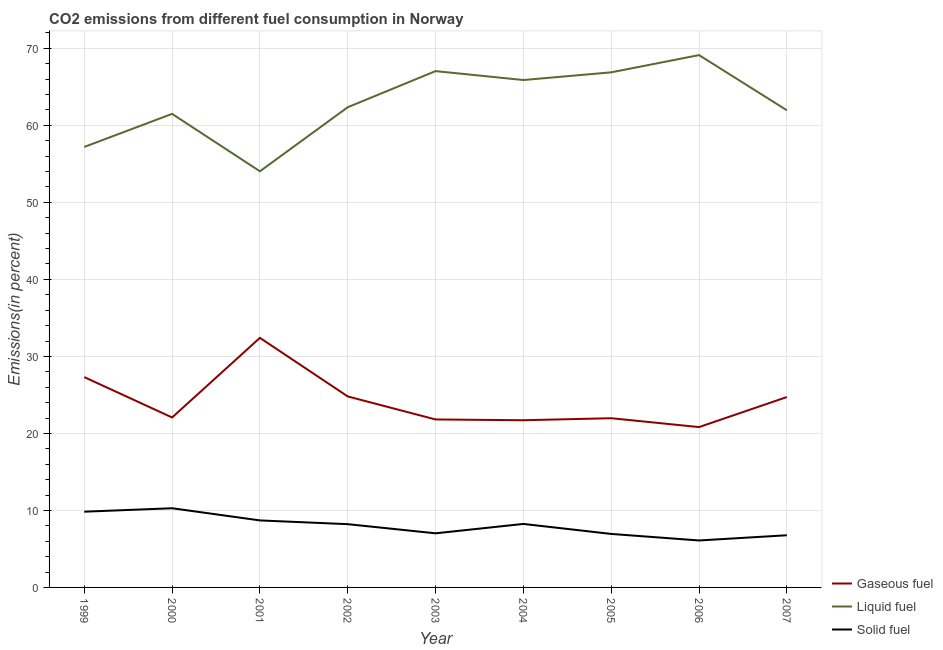How many different coloured lines are there?
Give a very brief answer. 3. Does the line corresponding to percentage of gaseous fuel emission intersect with the line corresponding to percentage of solid fuel emission?
Keep it short and to the point. No. What is the percentage of solid fuel emission in 2002?
Give a very brief answer. 8.22. Across all years, what is the maximum percentage of gaseous fuel emission?
Offer a terse response. 32.41. Across all years, what is the minimum percentage of solid fuel emission?
Give a very brief answer. 6.1. In which year was the percentage of gaseous fuel emission maximum?
Your answer should be compact. 2001. In which year was the percentage of solid fuel emission minimum?
Ensure brevity in your answer.  2006. What is the total percentage of solid fuel emission in the graph?
Your answer should be very brief. 72.13. What is the difference between the percentage of gaseous fuel emission in 2001 and that in 2007?
Ensure brevity in your answer.  7.69. What is the difference between the percentage of liquid fuel emission in 1999 and the percentage of gaseous fuel emission in 2001?
Offer a terse response. 24.79. What is the average percentage of liquid fuel emission per year?
Your answer should be compact. 62.89. In the year 2001, what is the difference between the percentage of gaseous fuel emission and percentage of solid fuel emission?
Keep it short and to the point. 23.71. In how many years, is the percentage of solid fuel emission greater than 26 %?
Your answer should be very brief. 0. What is the ratio of the percentage of liquid fuel emission in 2002 to that in 2004?
Make the answer very short. 0.95. Is the percentage of liquid fuel emission in 2001 less than that in 2002?
Provide a succinct answer. Yes. Is the difference between the percentage of liquid fuel emission in 2000 and 2006 greater than the difference between the percentage of solid fuel emission in 2000 and 2006?
Provide a succinct answer. No. What is the difference between the highest and the second highest percentage of liquid fuel emission?
Ensure brevity in your answer.  2.08. What is the difference between the highest and the lowest percentage of solid fuel emission?
Provide a short and direct response. 4.18. Is it the case that in every year, the sum of the percentage of gaseous fuel emission and percentage of liquid fuel emission is greater than the percentage of solid fuel emission?
Provide a succinct answer. Yes. Does the percentage of gaseous fuel emission monotonically increase over the years?
Ensure brevity in your answer.  No. How many years are there in the graph?
Your answer should be compact. 9. Does the graph contain grids?
Your answer should be compact. Yes. Where does the legend appear in the graph?
Your answer should be very brief. Bottom right. What is the title of the graph?
Offer a very short reply. CO2 emissions from different fuel consumption in Norway. Does "Gaseous fuel" appear as one of the legend labels in the graph?
Keep it short and to the point. Yes. What is the label or title of the X-axis?
Make the answer very short. Year. What is the label or title of the Y-axis?
Offer a very short reply. Emissions(in percent). What is the Emissions(in percent) in Gaseous fuel in 1999?
Offer a terse response. 27.31. What is the Emissions(in percent) of Liquid fuel in 1999?
Your answer should be very brief. 57.2. What is the Emissions(in percent) in Solid fuel in 1999?
Offer a very short reply. 9.83. What is the Emissions(in percent) in Gaseous fuel in 2000?
Your answer should be compact. 22.07. What is the Emissions(in percent) in Liquid fuel in 2000?
Your response must be concise. 61.49. What is the Emissions(in percent) of Solid fuel in 2000?
Provide a succinct answer. 10.28. What is the Emissions(in percent) of Gaseous fuel in 2001?
Offer a very short reply. 32.41. What is the Emissions(in percent) of Liquid fuel in 2001?
Keep it short and to the point. 54.04. What is the Emissions(in percent) in Solid fuel in 2001?
Your answer should be very brief. 8.7. What is the Emissions(in percent) in Gaseous fuel in 2002?
Your answer should be very brief. 24.8. What is the Emissions(in percent) of Liquid fuel in 2002?
Offer a very short reply. 62.36. What is the Emissions(in percent) of Solid fuel in 2002?
Keep it short and to the point. 8.22. What is the Emissions(in percent) of Gaseous fuel in 2003?
Your answer should be compact. 21.81. What is the Emissions(in percent) in Liquid fuel in 2003?
Offer a very short reply. 67.05. What is the Emissions(in percent) of Solid fuel in 2003?
Make the answer very short. 7.03. What is the Emissions(in percent) in Gaseous fuel in 2004?
Provide a short and direct response. 21.71. What is the Emissions(in percent) in Liquid fuel in 2004?
Provide a succinct answer. 65.89. What is the Emissions(in percent) in Solid fuel in 2004?
Your answer should be very brief. 8.25. What is the Emissions(in percent) in Gaseous fuel in 2005?
Provide a short and direct response. 21.97. What is the Emissions(in percent) in Liquid fuel in 2005?
Make the answer very short. 66.89. What is the Emissions(in percent) of Solid fuel in 2005?
Give a very brief answer. 6.95. What is the Emissions(in percent) in Gaseous fuel in 2006?
Keep it short and to the point. 20.82. What is the Emissions(in percent) of Liquid fuel in 2006?
Your answer should be compact. 69.13. What is the Emissions(in percent) in Solid fuel in 2006?
Ensure brevity in your answer.  6.1. What is the Emissions(in percent) in Gaseous fuel in 2007?
Provide a succinct answer. 24.72. What is the Emissions(in percent) of Liquid fuel in 2007?
Your response must be concise. 61.96. What is the Emissions(in percent) in Solid fuel in 2007?
Your response must be concise. 6.77. Across all years, what is the maximum Emissions(in percent) of Gaseous fuel?
Provide a succinct answer. 32.41. Across all years, what is the maximum Emissions(in percent) of Liquid fuel?
Ensure brevity in your answer.  69.13. Across all years, what is the maximum Emissions(in percent) of Solid fuel?
Give a very brief answer. 10.28. Across all years, what is the minimum Emissions(in percent) of Gaseous fuel?
Provide a succinct answer. 20.82. Across all years, what is the minimum Emissions(in percent) in Liquid fuel?
Your answer should be very brief. 54.04. Across all years, what is the minimum Emissions(in percent) of Solid fuel?
Give a very brief answer. 6.1. What is the total Emissions(in percent) in Gaseous fuel in the graph?
Keep it short and to the point. 217.63. What is the total Emissions(in percent) in Liquid fuel in the graph?
Your answer should be very brief. 566.01. What is the total Emissions(in percent) in Solid fuel in the graph?
Offer a very short reply. 72.13. What is the difference between the Emissions(in percent) of Gaseous fuel in 1999 and that in 2000?
Provide a succinct answer. 5.24. What is the difference between the Emissions(in percent) of Liquid fuel in 1999 and that in 2000?
Keep it short and to the point. -4.29. What is the difference between the Emissions(in percent) in Solid fuel in 1999 and that in 2000?
Ensure brevity in your answer.  -0.45. What is the difference between the Emissions(in percent) of Gaseous fuel in 1999 and that in 2001?
Provide a short and direct response. -5.1. What is the difference between the Emissions(in percent) in Liquid fuel in 1999 and that in 2001?
Give a very brief answer. 3.16. What is the difference between the Emissions(in percent) in Solid fuel in 1999 and that in 2001?
Offer a terse response. 1.13. What is the difference between the Emissions(in percent) of Gaseous fuel in 1999 and that in 2002?
Make the answer very short. 2.51. What is the difference between the Emissions(in percent) of Liquid fuel in 1999 and that in 2002?
Offer a terse response. -5.16. What is the difference between the Emissions(in percent) of Solid fuel in 1999 and that in 2002?
Provide a short and direct response. 1.62. What is the difference between the Emissions(in percent) of Gaseous fuel in 1999 and that in 2003?
Keep it short and to the point. 5.5. What is the difference between the Emissions(in percent) of Liquid fuel in 1999 and that in 2003?
Provide a succinct answer. -9.85. What is the difference between the Emissions(in percent) in Solid fuel in 1999 and that in 2003?
Your response must be concise. 2.81. What is the difference between the Emissions(in percent) in Gaseous fuel in 1999 and that in 2004?
Provide a succinct answer. 5.6. What is the difference between the Emissions(in percent) in Liquid fuel in 1999 and that in 2004?
Offer a terse response. -8.69. What is the difference between the Emissions(in percent) in Solid fuel in 1999 and that in 2004?
Make the answer very short. 1.59. What is the difference between the Emissions(in percent) of Gaseous fuel in 1999 and that in 2005?
Ensure brevity in your answer.  5.34. What is the difference between the Emissions(in percent) of Liquid fuel in 1999 and that in 2005?
Make the answer very short. -9.69. What is the difference between the Emissions(in percent) in Solid fuel in 1999 and that in 2005?
Provide a succinct answer. 2.89. What is the difference between the Emissions(in percent) in Gaseous fuel in 1999 and that in 2006?
Keep it short and to the point. 6.49. What is the difference between the Emissions(in percent) of Liquid fuel in 1999 and that in 2006?
Make the answer very short. -11.93. What is the difference between the Emissions(in percent) in Solid fuel in 1999 and that in 2006?
Give a very brief answer. 3.74. What is the difference between the Emissions(in percent) in Gaseous fuel in 1999 and that in 2007?
Keep it short and to the point. 2.59. What is the difference between the Emissions(in percent) in Liquid fuel in 1999 and that in 2007?
Make the answer very short. -4.76. What is the difference between the Emissions(in percent) in Solid fuel in 1999 and that in 2007?
Make the answer very short. 3.06. What is the difference between the Emissions(in percent) of Gaseous fuel in 2000 and that in 2001?
Your response must be concise. -10.34. What is the difference between the Emissions(in percent) in Liquid fuel in 2000 and that in 2001?
Your answer should be very brief. 7.46. What is the difference between the Emissions(in percent) in Solid fuel in 2000 and that in 2001?
Offer a very short reply. 1.58. What is the difference between the Emissions(in percent) of Gaseous fuel in 2000 and that in 2002?
Provide a short and direct response. -2.73. What is the difference between the Emissions(in percent) in Liquid fuel in 2000 and that in 2002?
Your response must be concise. -0.86. What is the difference between the Emissions(in percent) in Solid fuel in 2000 and that in 2002?
Provide a succinct answer. 2.07. What is the difference between the Emissions(in percent) of Gaseous fuel in 2000 and that in 2003?
Your answer should be very brief. 0.26. What is the difference between the Emissions(in percent) of Liquid fuel in 2000 and that in 2003?
Offer a terse response. -5.55. What is the difference between the Emissions(in percent) in Solid fuel in 2000 and that in 2003?
Your answer should be compact. 3.25. What is the difference between the Emissions(in percent) of Gaseous fuel in 2000 and that in 2004?
Provide a succinct answer. 0.36. What is the difference between the Emissions(in percent) in Liquid fuel in 2000 and that in 2004?
Your answer should be very brief. -4.4. What is the difference between the Emissions(in percent) of Solid fuel in 2000 and that in 2004?
Provide a succinct answer. 2.04. What is the difference between the Emissions(in percent) of Gaseous fuel in 2000 and that in 2005?
Provide a succinct answer. 0.1. What is the difference between the Emissions(in percent) of Liquid fuel in 2000 and that in 2005?
Make the answer very short. -5.39. What is the difference between the Emissions(in percent) of Solid fuel in 2000 and that in 2005?
Offer a very short reply. 3.33. What is the difference between the Emissions(in percent) of Gaseous fuel in 2000 and that in 2006?
Give a very brief answer. 1.25. What is the difference between the Emissions(in percent) of Liquid fuel in 2000 and that in 2006?
Give a very brief answer. -7.63. What is the difference between the Emissions(in percent) of Solid fuel in 2000 and that in 2006?
Provide a succinct answer. 4.18. What is the difference between the Emissions(in percent) of Gaseous fuel in 2000 and that in 2007?
Offer a very short reply. -2.65. What is the difference between the Emissions(in percent) of Liquid fuel in 2000 and that in 2007?
Ensure brevity in your answer.  -0.47. What is the difference between the Emissions(in percent) in Solid fuel in 2000 and that in 2007?
Your response must be concise. 3.51. What is the difference between the Emissions(in percent) of Gaseous fuel in 2001 and that in 2002?
Offer a very short reply. 7.61. What is the difference between the Emissions(in percent) of Liquid fuel in 2001 and that in 2002?
Your answer should be compact. -8.32. What is the difference between the Emissions(in percent) in Solid fuel in 2001 and that in 2002?
Your answer should be compact. 0.49. What is the difference between the Emissions(in percent) in Gaseous fuel in 2001 and that in 2003?
Your answer should be compact. 10.6. What is the difference between the Emissions(in percent) in Liquid fuel in 2001 and that in 2003?
Give a very brief answer. -13.01. What is the difference between the Emissions(in percent) of Solid fuel in 2001 and that in 2003?
Keep it short and to the point. 1.67. What is the difference between the Emissions(in percent) of Gaseous fuel in 2001 and that in 2004?
Keep it short and to the point. 10.7. What is the difference between the Emissions(in percent) in Liquid fuel in 2001 and that in 2004?
Ensure brevity in your answer.  -11.85. What is the difference between the Emissions(in percent) in Solid fuel in 2001 and that in 2004?
Provide a succinct answer. 0.46. What is the difference between the Emissions(in percent) in Gaseous fuel in 2001 and that in 2005?
Ensure brevity in your answer.  10.44. What is the difference between the Emissions(in percent) of Liquid fuel in 2001 and that in 2005?
Keep it short and to the point. -12.85. What is the difference between the Emissions(in percent) in Solid fuel in 2001 and that in 2005?
Give a very brief answer. 1.75. What is the difference between the Emissions(in percent) of Gaseous fuel in 2001 and that in 2006?
Offer a very short reply. 11.59. What is the difference between the Emissions(in percent) of Liquid fuel in 2001 and that in 2006?
Provide a succinct answer. -15.09. What is the difference between the Emissions(in percent) of Solid fuel in 2001 and that in 2006?
Keep it short and to the point. 2.6. What is the difference between the Emissions(in percent) of Gaseous fuel in 2001 and that in 2007?
Keep it short and to the point. 7.69. What is the difference between the Emissions(in percent) of Liquid fuel in 2001 and that in 2007?
Provide a succinct answer. -7.92. What is the difference between the Emissions(in percent) in Solid fuel in 2001 and that in 2007?
Keep it short and to the point. 1.93. What is the difference between the Emissions(in percent) of Gaseous fuel in 2002 and that in 2003?
Provide a short and direct response. 2.99. What is the difference between the Emissions(in percent) of Liquid fuel in 2002 and that in 2003?
Make the answer very short. -4.69. What is the difference between the Emissions(in percent) of Solid fuel in 2002 and that in 2003?
Ensure brevity in your answer.  1.19. What is the difference between the Emissions(in percent) in Gaseous fuel in 2002 and that in 2004?
Offer a terse response. 3.09. What is the difference between the Emissions(in percent) in Liquid fuel in 2002 and that in 2004?
Provide a short and direct response. -3.53. What is the difference between the Emissions(in percent) of Solid fuel in 2002 and that in 2004?
Provide a succinct answer. -0.03. What is the difference between the Emissions(in percent) of Gaseous fuel in 2002 and that in 2005?
Keep it short and to the point. 2.83. What is the difference between the Emissions(in percent) in Liquid fuel in 2002 and that in 2005?
Provide a succinct answer. -4.53. What is the difference between the Emissions(in percent) in Solid fuel in 2002 and that in 2005?
Offer a very short reply. 1.27. What is the difference between the Emissions(in percent) in Gaseous fuel in 2002 and that in 2006?
Offer a terse response. 3.98. What is the difference between the Emissions(in percent) in Liquid fuel in 2002 and that in 2006?
Offer a terse response. -6.77. What is the difference between the Emissions(in percent) of Solid fuel in 2002 and that in 2006?
Provide a short and direct response. 2.12. What is the difference between the Emissions(in percent) of Gaseous fuel in 2002 and that in 2007?
Make the answer very short. 0.08. What is the difference between the Emissions(in percent) of Liquid fuel in 2002 and that in 2007?
Offer a very short reply. 0.39. What is the difference between the Emissions(in percent) in Solid fuel in 2002 and that in 2007?
Ensure brevity in your answer.  1.44. What is the difference between the Emissions(in percent) in Gaseous fuel in 2003 and that in 2004?
Offer a terse response. 0.1. What is the difference between the Emissions(in percent) of Liquid fuel in 2003 and that in 2004?
Provide a short and direct response. 1.16. What is the difference between the Emissions(in percent) of Solid fuel in 2003 and that in 2004?
Keep it short and to the point. -1.22. What is the difference between the Emissions(in percent) in Gaseous fuel in 2003 and that in 2005?
Keep it short and to the point. -0.16. What is the difference between the Emissions(in percent) in Liquid fuel in 2003 and that in 2005?
Your response must be concise. 0.16. What is the difference between the Emissions(in percent) of Solid fuel in 2003 and that in 2005?
Your answer should be compact. 0.08. What is the difference between the Emissions(in percent) of Gaseous fuel in 2003 and that in 2006?
Your answer should be compact. 0.99. What is the difference between the Emissions(in percent) in Liquid fuel in 2003 and that in 2006?
Your answer should be compact. -2.08. What is the difference between the Emissions(in percent) in Solid fuel in 2003 and that in 2006?
Keep it short and to the point. 0.93. What is the difference between the Emissions(in percent) in Gaseous fuel in 2003 and that in 2007?
Ensure brevity in your answer.  -2.91. What is the difference between the Emissions(in percent) in Liquid fuel in 2003 and that in 2007?
Ensure brevity in your answer.  5.08. What is the difference between the Emissions(in percent) in Solid fuel in 2003 and that in 2007?
Ensure brevity in your answer.  0.25. What is the difference between the Emissions(in percent) in Gaseous fuel in 2004 and that in 2005?
Provide a succinct answer. -0.26. What is the difference between the Emissions(in percent) in Liquid fuel in 2004 and that in 2005?
Provide a short and direct response. -1. What is the difference between the Emissions(in percent) of Solid fuel in 2004 and that in 2005?
Provide a short and direct response. 1.3. What is the difference between the Emissions(in percent) of Gaseous fuel in 2004 and that in 2006?
Your answer should be very brief. 0.89. What is the difference between the Emissions(in percent) of Liquid fuel in 2004 and that in 2006?
Offer a terse response. -3.24. What is the difference between the Emissions(in percent) of Solid fuel in 2004 and that in 2006?
Your response must be concise. 2.15. What is the difference between the Emissions(in percent) of Gaseous fuel in 2004 and that in 2007?
Offer a very short reply. -3.01. What is the difference between the Emissions(in percent) of Liquid fuel in 2004 and that in 2007?
Your response must be concise. 3.93. What is the difference between the Emissions(in percent) in Solid fuel in 2004 and that in 2007?
Provide a short and direct response. 1.47. What is the difference between the Emissions(in percent) in Gaseous fuel in 2005 and that in 2006?
Offer a terse response. 1.15. What is the difference between the Emissions(in percent) of Liquid fuel in 2005 and that in 2006?
Your answer should be very brief. -2.24. What is the difference between the Emissions(in percent) in Solid fuel in 2005 and that in 2006?
Give a very brief answer. 0.85. What is the difference between the Emissions(in percent) in Gaseous fuel in 2005 and that in 2007?
Your answer should be very brief. -2.75. What is the difference between the Emissions(in percent) of Liquid fuel in 2005 and that in 2007?
Your answer should be compact. 4.93. What is the difference between the Emissions(in percent) of Solid fuel in 2005 and that in 2007?
Provide a succinct answer. 0.17. What is the difference between the Emissions(in percent) in Gaseous fuel in 2006 and that in 2007?
Provide a short and direct response. -3.9. What is the difference between the Emissions(in percent) of Liquid fuel in 2006 and that in 2007?
Your response must be concise. 7.16. What is the difference between the Emissions(in percent) in Solid fuel in 2006 and that in 2007?
Provide a short and direct response. -0.68. What is the difference between the Emissions(in percent) of Gaseous fuel in 1999 and the Emissions(in percent) of Liquid fuel in 2000?
Provide a succinct answer. -34.18. What is the difference between the Emissions(in percent) in Gaseous fuel in 1999 and the Emissions(in percent) in Solid fuel in 2000?
Ensure brevity in your answer.  17.03. What is the difference between the Emissions(in percent) of Liquid fuel in 1999 and the Emissions(in percent) of Solid fuel in 2000?
Provide a short and direct response. 46.92. What is the difference between the Emissions(in percent) of Gaseous fuel in 1999 and the Emissions(in percent) of Liquid fuel in 2001?
Your answer should be compact. -26.73. What is the difference between the Emissions(in percent) of Gaseous fuel in 1999 and the Emissions(in percent) of Solid fuel in 2001?
Your answer should be compact. 18.61. What is the difference between the Emissions(in percent) of Liquid fuel in 1999 and the Emissions(in percent) of Solid fuel in 2001?
Your response must be concise. 48.5. What is the difference between the Emissions(in percent) of Gaseous fuel in 1999 and the Emissions(in percent) of Liquid fuel in 2002?
Your answer should be compact. -35.05. What is the difference between the Emissions(in percent) of Gaseous fuel in 1999 and the Emissions(in percent) of Solid fuel in 2002?
Keep it short and to the point. 19.1. What is the difference between the Emissions(in percent) of Liquid fuel in 1999 and the Emissions(in percent) of Solid fuel in 2002?
Offer a terse response. 48.98. What is the difference between the Emissions(in percent) of Gaseous fuel in 1999 and the Emissions(in percent) of Liquid fuel in 2003?
Keep it short and to the point. -39.74. What is the difference between the Emissions(in percent) of Gaseous fuel in 1999 and the Emissions(in percent) of Solid fuel in 2003?
Your answer should be compact. 20.28. What is the difference between the Emissions(in percent) in Liquid fuel in 1999 and the Emissions(in percent) in Solid fuel in 2003?
Your answer should be compact. 50.17. What is the difference between the Emissions(in percent) of Gaseous fuel in 1999 and the Emissions(in percent) of Liquid fuel in 2004?
Make the answer very short. -38.58. What is the difference between the Emissions(in percent) of Gaseous fuel in 1999 and the Emissions(in percent) of Solid fuel in 2004?
Make the answer very short. 19.07. What is the difference between the Emissions(in percent) in Liquid fuel in 1999 and the Emissions(in percent) in Solid fuel in 2004?
Keep it short and to the point. 48.95. What is the difference between the Emissions(in percent) of Gaseous fuel in 1999 and the Emissions(in percent) of Liquid fuel in 2005?
Provide a short and direct response. -39.58. What is the difference between the Emissions(in percent) in Gaseous fuel in 1999 and the Emissions(in percent) in Solid fuel in 2005?
Offer a terse response. 20.36. What is the difference between the Emissions(in percent) of Liquid fuel in 1999 and the Emissions(in percent) of Solid fuel in 2005?
Offer a terse response. 50.25. What is the difference between the Emissions(in percent) in Gaseous fuel in 1999 and the Emissions(in percent) in Liquid fuel in 2006?
Provide a short and direct response. -41.82. What is the difference between the Emissions(in percent) in Gaseous fuel in 1999 and the Emissions(in percent) in Solid fuel in 2006?
Provide a short and direct response. 21.21. What is the difference between the Emissions(in percent) of Liquid fuel in 1999 and the Emissions(in percent) of Solid fuel in 2006?
Ensure brevity in your answer.  51.1. What is the difference between the Emissions(in percent) in Gaseous fuel in 1999 and the Emissions(in percent) in Liquid fuel in 2007?
Offer a terse response. -34.65. What is the difference between the Emissions(in percent) of Gaseous fuel in 1999 and the Emissions(in percent) of Solid fuel in 2007?
Ensure brevity in your answer.  20.54. What is the difference between the Emissions(in percent) of Liquid fuel in 1999 and the Emissions(in percent) of Solid fuel in 2007?
Make the answer very short. 50.42. What is the difference between the Emissions(in percent) of Gaseous fuel in 2000 and the Emissions(in percent) of Liquid fuel in 2001?
Ensure brevity in your answer.  -31.97. What is the difference between the Emissions(in percent) of Gaseous fuel in 2000 and the Emissions(in percent) of Solid fuel in 2001?
Give a very brief answer. 13.37. What is the difference between the Emissions(in percent) in Liquid fuel in 2000 and the Emissions(in percent) in Solid fuel in 2001?
Keep it short and to the point. 52.79. What is the difference between the Emissions(in percent) of Gaseous fuel in 2000 and the Emissions(in percent) of Liquid fuel in 2002?
Your answer should be very brief. -40.29. What is the difference between the Emissions(in percent) of Gaseous fuel in 2000 and the Emissions(in percent) of Solid fuel in 2002?
Provide a succinct answer. 13.85. What is the difference between the Emissions(in percent) in Liquid fuel in 2000 and the Emissions(in percent) in Solid fuel in 2002?
Your answer should be compact. 53.28. What is the difference between the Emissions(in percent) of Gaseous fuel in 2000 and the Emissions(in percent) of Liquid fuel in 2003?
Offer a terse response. -44.98. What is the difference between the Emissions(in percent) of Gaseous fuel in 2000 and the Emissions(in percent) of Solid fuel in 2003?
Provide a short and direct response. 15.04. What is the difference between the Emissions(in percent) of Liquid fuel in 2000 and the Emissions(in percent) of Solid fuel in 2003?
Offer a terse response. 54.47. What is the difference between the Emissions(in percent) in Gaseous fuel in 2000 and the Emissions(in percent) in Liquid fuel in 2004?
Your answer should be compact. -43.82. What is the difference between the Emissions(in percent) in Gaseous fuel in 2000 and the Emissions(in percent) in Solid fuel in 2004?
Your response must be concise. 13.82. What is the difference between the Emissions(in percent) in Liquid fuel in 2000 and the Emissions(in percent) in Solid fuel in 2004?
Provide a short and direct response. 53.25. What is the difference between the Emissions(in percent) in Gaseous fuel in 2000 and the Emissions(in percent) in Liquid fuel in 2005?
Make the answer very short. -44.82. What is the difference between the Emissions(in percent) in Gaseous fuel in 2000 and the Emissions(in percent) in Solid fuel in 2005?
Make the answer very short. 15.12. What is the difference between the Emissions(in percent) of Liquid fuel in 2000 and the Emissions(in percent) of Solid fuel in 2005?
Offer a very short reply. 54.55. What is the difference between the Emissions(in percent) in Gaseous fuel in 2000 and the Emissions(in percent) in Liquid fuel in 2006?
Provide a short and direct response. -47.06. What is the difference between the Emissions(in percent) of Gaseous fuel in 2000 and the Emissions(in percent) of Solid fuel in 2006?
Give a very brief answer. 15.97. What is the difference between the Emissions(in percent) in Liquid fuel in 2000 and the Emissions(in percent) in Solid fuel in 2006?
Offer a terse response. 55.4. What is the difference between the Emissions(in percent) in Gaseous fuel in 2000 and the Emissions(in percent) in Liquid fuel in 2007?
Make the answer very short. -39.89. What is the difference between the Emissions(in percent) of Gaseous fuel in 2000 and the Emissions(in percent) of Solid fuel in 2007?
Offer a terse response. 15.3. What is the difference between the Emissions(in percent) of Liquid fuel in 2000 and the Emissions(in percent) of Solid fuel in 2007?
Your answer should be very brief. 54.72. What is the difference between the Emissions(in percent) of Gaseous fuel in 2001 and the Emissions(in percent) of Liquid fuel in 2002?
Give a very brief answer. -29.95. What is the difference between the Emissions(in percent) in Gaseous fuel in 2001 and the Emissions(in percent) in Solid fuel in 2002?
Your response must be concise. 24.19. What is the difference between the Emissions(in percent) of Liquid fuel in 2001 and the Emissions(in percent) of Solid fuel in 2002?
Provide a short and direct response. 45.82. What is the difference between the Emissions(in percent) in Gaseous fuel in 2001 and the Emissions(in percent) in Liquid fuel in 2003?
Keep it short and to the point. -34.64. What is the difference between the Emissions(in percent) of Gaseous fuel in 2001 and the Emissions(in percent) of Solid fuel in 2003?
Provide a succinct answer. 25.38. What is the difference between the Emissions(in percent) in Liquid fuel in 2001 and the Emissions(in percent) in Solid fuel in 2003?
Your answer should be compact. 47.01. What is the difference between the Emissions(in percent) of Gaseous fuel in 2001 and the Emissions(in percent) of Liquid fuel in 2004?
Offer a terse response. -33.48. What is the difference between the Emissions(in percent) of Gaseous fuel in 2001 and the Emissions(in percent) of Solid fuel in 2004?
Your answer should be very brief. 24.16. What is the difference between the Emissions(in percent) in Liquid fuel in 2001 and the Emissions(in percent) in Solid fuel in 2004?
Your answer should be very brief. 45.79. What is the difference between the Emissions(in percent) of Gaseous fuel in 2001 and the Emissions(in percent) of Liquid fuel in 2005?
Provide a short and direct response. -34.48. What is the difference between the Emissions(in percent) of Gaseous fuel in 2001 and the Emissions(in percent) of Solid fuel in 2005?
Provide a short and direct response. 25.46. What is the difference between the Emissions(in percent) of Liquid fuel in 2001 and the Emissions(in percent) of Solid fuel in 2005?
Provide a short and direct response. 47.09. What is the difference between the Emissions(in percent) of Gaseous fuel in 2001 and the Emissions(in percent) of Liquid fuel in 2006?
Your response must be concise. -36.72. What is the difference between the Emissions(in percent) of Gaseous fuel in 2001 and the Emissions(in percent) of Solid fuel in 2006?
Your answer should be very brief. 26.31. What is the difference between the Emissions(in percent) in Liquid fuel in 2001 and the Emissions(in percent) in Solid fuel in 2006?
Provide a succinct answer. 47.94. What is the difference between the Emissions(in percent) in Gaseous fuel in 2001 and the Emissions(in percent) in Liquid fuel in 2007?
Your answer should be compact. -29.55. What is the difference between the Emissions(in percent) of Gaseous fuel in 2001 and the Emissions(in percent) of Solid fuel in 2007?
Provide a short and direct response. 25.63. What is the difference between the Emissions(in percent) of Liquid fuel in 2001 and the Emissions(in percent) of Solid fuel in 2007?
Make the answer very short. 47.26. What is the difference between the Emissions(in percent) of Gaseous fuel in 2002 and the Emissions(in percent) of Liquid fuel in 2003?
Make the answer very short. -42.25. What is the difference between the Emissions(in percent) in Gaseous fuel in 2002 and the Emissions(in percent) in Solid fuel in 2003?
Your answer should be very brief. 17.77. What is the difference between the Emissions(in percent) of Liquid fuel in 2002 and the Emissions(in percent) of Solid fuel in 2003?
Keep it short and to the point. 55.33. What is the difference between the Emissions(in percent) of Gaseous fuel in 2002 and the Emissions(in percent) of Liquid fuel in 2004?
Offer a very short reply. -41.09. What is the difference between the Emissions(in percent) in Gaseous fuel in 2002 and the Emissions(in percent) in Solid fuel in 2004?
Your answer should be very brief. 16.56. What is the difference between the Emissions(in percent) in Liquid fuel in 2002 and the Emissions(in percent) in Solid fuel in 2004?
Offer a very short reply. 54.11. What is the difference between the Emissions(in percent) in Gaseous fuel in 2002 and the Emissions(in percent) in Liquid fuel in 2005?
Your answer should be compact. -42.09. What is the difference between the Emissions(in percent) of Gaseous fuel in 2002 and the Emissions(in percent) of Solid fuel in 2005?
Offer a terse response. 17.85. What is the difference between the Emissions(in percent) of Liquid fuel in 2002 and the Emissions(in percent) of Solid fuel in 2005?
Your answer should be very brief. 55.41. What is the difference between the Emissions(in percent) in Gaseous fuel in 2002 and the Emissions(in percent) in Liquid fuel in 2006?
Offer a very short reply. -44.33. What is the difference between the Emissions(in percent) of Gaseous fuel in 2002 and the Emissions(in percent) of Solid fuel in 2006?
Ensure brevity in your answer.  18.7. What is the difference between the Emissions(in percent) of Liquid fuel in 2002 and the Emissions(in percent) of Solid fuel in 2006?
Offer a very short reply. 56.26. What is the difference between the Emissions(in percent) in Gaseous fuel in 2002 and the Emissions(in percent) in Liquid fuel in 2007?
Keep it short and to the point. -37.16. What is the difference between the Emissions(in percent) in Gaseous fuel in 2002 and the Emissions(in percent) in Solid fuel in 2007?
Offer a very short reply. 18.03. What is the difference between the Emissions(in percent) in Liquid fuel in 2002 and the Emissions(in percent) in Solid fuel in 2007?
Offer a terse response. 55.58. What is the difference between the Emissions(in percent) in Gaseous fuel in 2003 and the Emissions(in percent) in Liquid fuel in 2004?
Your answer should be very brief. -44.08. What is the difference between the Emissions(in percent) in Gaseous fuel in 2003 and the Emissions(in percent) in Solid fuel in 2004?
Ensure brevity in your answer.  13.57. What is the difference between the Emissions(in percent) in Liquid fuel in 2003 and the Emissions(in percent) in Solid fuel in 2004?
Ensure brevity in your answer.  58.8. What is the difference between the Emissions(in percent) in Gaseous fuel in 2003 and the Emissions(in percent) in Liquid fuel in 2005?
Ensure brevity in your answer.  -45.08. What is the difference between the Emissions(in percent) of Gaseous fuel in 2003 and the Emissions(in percent) of Solid fuel in 2005?
Give a very brief answer. 14.87. What is the difference between the Emissions(in percent) in Liquid fuel in 2003 and the Emissions(in percent) in Solid fuel in 2005?
Make the answer very short. 60.1. What is the difference between the Emissions(in percent) of Gaseous fuel in 2003 and the Emissions(in percent) of Liquid fuel in 2006?
Provide a succinct answer. -47.31. What is the difference between the Emissions(in percent) in Gaseous fuel in 2003 and the Emissions(in percent) in Solid fuel in 2006?
Your response must be concise. 15.71. What is the difference between the Emissions(in percent) of Liquid fuel in 2003 and the Emissions(in percent) of Solid fuel in 2006?
Make the answer very short. 60.95. What is the difference between the Emissions(in percent) in Gaseous fuel in 2003 and the Emissions(in percent) in Liquid fuel in 2007?
Give a very brief answer. -40.15. What is the difference between the Emissions(in percent) in Gaseous fuel in 2003 and the Emissions(in percent) in Solid fuel in 2007?
Provide a succinct answer. 15.04. What is the difference between the Emissions(in percent) in Liquid fuel in 2003 and the Emissions(in percent) in Solid fuel in 2007?
Your answer should be very brief. 60.27. What is the difference between the Emissions(in percent) in Gaseous fuel in 2004 and the Emissions(in percent) in Liquid fuel in 2005?
Give a very brief answer. -45.18. What is the difference between the Emissions(in percent) of Gaseous fuel in 2004 and the Emissions(in percent) of Solid fuel in 2005?
Ensure brevity in your answer.  14.76. What is the difference between the Emissions(in percent) of Liquid fuel in 2004 and the Emissions(in percent) of Solid fuel in 2005?
Provide a short and direct response. 58.94. What is the difference between the Emissions(in percent) of Gaseous fuel in 2004 and the Emissions(in percent) of Liquid fuel in 2006?
Make the answer very short. -47.42. What is the difference between the Emissions(in percent) of Gaseous fuel in 2004 and the Emissions(in percent) of Solid fuel in 2006?
Keep it short and to the point. 15.61. What is the difference between the Emissions(in percent) in Liquid fuel in 2004 and the Emissions(in percent) in Solid fuel in 2006?
Offer a terse response. 59.79. What is the difference between the Emissions(in percent) of Gaseous fuel in 2004 and the Emissions(in percent) of Liquid fuel in 2007?
Provide a short and direct response. -40.25. What is the difference between the Emissions(in percent) in Gaseous fuel in 2004 and the Emissions(in percent) in Solid fuel in 2007?
Your answer should be compact. 14.94. What is the difference between the Emissions(in percent) of Liquid fuel in 2004 and the Emissions(in percent) of Solid fuel in 2007?
Your answer should be very brief. 59.12. What is the difference between the Emissions(in percent) in Gaseous fuel in 2005 and the Emissions(in percent) in Liquid fuel in 2006?
Make the answer very short. -47.15. What is the difference between the Emissions(in percent) of Gaseous fuel in 2005 and the Emissions(in percent) of Solid fuel in 2006?
Your answer should be very brief. 15.88. What is the difference between the Emissions(in percent) in Liquid fuel in 2005 and the Emissions(in percent) in Solid fuel in 2006?
Your answer should be very brief. 60.79. What is the difference between the Emissions(in percent) of Gaseous fuel in 2005 and the Emissions(in percent) of Liquid fuel in 2007?
Provide a short and direct response. -39.99. What is the difference between the Emissions(in percent) in Gaseous fuel in 2005 and the Emissions(in percent) in Solid fuel in 2007?
Give a very brief answer. 15.2. What is the difference between the Emissions(in percent) of Liquid fuel in 2005 and the Emissions(in percent) of Solid fuel in 2007?
Provide a short and direct response. 60.11. What is the difference between the Emissions(in percent) in Gaseous fuel in 2006 and the Emissions(in percent) in Liquid fuel in 2007?
Keep it short and to the point. -41.14. What is the difference between the Emissions(in percent) in Gaseous fuel in 2006 and the Emissions(in percent) in Solid fuel in 2007?
Make the answer very short. 14.05. What is the difference between the Emissions(in percent) in Liquid fuel in 2006 and the Emissions(in percent) in Solid fuel in 2007?
Give a very brief answer. 62.35. What is the average Emissions(in percent) of Gaseous fuel per year?
Offer a terse response. 24.18. What is the average Emissions(in percent) in Liquid fuel per year?
Give a very brief answer. 62.89. What is the average Emissions(in percent) in Solid fuel per year?
Provide a succinct answer. 8.01. In the year 1999, what is the difference between the Emissions(in percent) in Gaseous fuel and Emissions(in percent) in Liquid fuel?
Your response must be concise. -29.89. In the year 1999, what is the difference between the Emissions(in percent) of Gaseous fuel and Emissions(in percent) of Solid fuel?
Provide a short and direct response. 17.48. In the year 1999, what is the difference between the Emissions(in percent) of Liquid fuel and Emissions(in percent) of Solid fuel?
Offer a terse response. 47.36. In the year 2000, what is the difference between the Emissions(in percent) of Gaseous fuel and Emissions(in percent) of Liquid fuel?
Ensure brevity in your answer.  -39.42. In the year 2000, what is the difference between the Emissions(in percent) of Gaseous fuel and Emissions(in percent) of Solid fuel?
Ensure brevity in your answer.  11.79. In the year 2000, what is the difference between the Emissions(in percent) of Liquid fuel and Emissions(in percent) of Solid fuel?
Provide a succinct answer. 51.21. In the year 2001, what is the difference between the Emissions(in percent) in Gaseous fuel and Emissions(in percent) in Liquid fuel?
Your answer should be very brief. -21.63. In the year 2001, what is the difference between the Emissions(in percent) of Gaseous fuel and Emissions(in percent) of Solid fuel?
Offer a terse response. 23.71. In the year 2001, what is the difference between the Emissions(in percent) in Liquid fuel and Emissions(in percent) in Solid fuel?
Offer a terse response. 45.34. In the year 2002, what is the difference between the Emissions(in percent) in Gaseous fuel and Emissions(in percent) in Liquid fuel?
Ensure brevity in your answer.  -37.55. In the year 2002, what is the difference between the Emissions(in percent) of Gaseous fuel and Emissions(in percent) of Solid fuel?
Offer a very short reply. 16.59. In the year 2002, what is the difference between the Emissions(in percent) of Liquid fuel and Emissions(in percent) of Solid fuel?
Your answer should be compact. 54.14. In the year 2003, what is the difference between the Emissions(in percent) in Gaseous fuel and Emissions(in percent) in Liquid fuel?
Provide a succinct answer. -45.23. In the year 2003, what is the difference between the Emissions(in percent) in Gaseous fuel and Emissions(in percent) in Solid fuel?
Offer a terse response. 14.79. In the year 2003, what is the difference between the Emissions(in percent) of Liquid fuel and Emissions(in percent) of Solid fuel?
Offer a terse response. 60.02. In the year 2004, what is the difference between the Emissions(in percent) of Gaseous fuel and Emissions(in percent) of Liquid fuel?
Keep it short and to the point. -44.18. In the year 2004, what is the difference between the Emissions(in percent) of Gaseous fuel and Emissions(in percent) of Solid fuel?
Offer a terse response. 13.47. In the year 2004, what is the difference between the Emissions(in percent) in Liquid fuel and Emissions(in percent) in Solid fuel?
Offer a terse response. 57.64. In the year 2005, what is the difference between the Emissions(in percent) in Gaseous fuel and Emissions(in percent) in Liquid fuel?
Offer a very short reply. -44.91. In the year 2005, what is the difference between the Emissions(in percent) of Gaseous fuel and Emissions(in percent) of Solid fuel?
Make the answer very short. 15.03. In the year 2005, what is the difference between the Emissions(in percent) of Liquid fuel and Emissions(in percent) of Solid fuel?
Provide a short and direct response. 59.94. In the year 2006, what is the difference between the Emissions(in percent) in Gaseous fuel and Emissions(in percent) in Liquid fuel?
Give a very brief answer. -48.31. In the year 2006, what is the difference between the Emissions(in percent) of Gaseous fuel and Emissions(in percent) of Solid fuel?
Offer a terse response. 14.72. In the year 2006, what is the difference between the Emissions(in percent) of Liquid fuel and Emissions(in percent) of Solid fuel?
Make the answer very short. 63.03. In the year 2007, what is the difference between the Emissions(in percent) in Gaseous fuel and Emissions(in percent) in Liquid fuel?
Ensure brevity in your answer.  -37.24. In the year 2007, what is the difference between the Emissions(in percent) of Gaseous fuel and Emissions(in percent) of Solid fuel?
Provide a short and direct response. 17.95. In the year 2007, what is the difference between the Emissions(in percent) in Liquid fuel and Emissions(in percent) in Solid fuel?
Provide a short and direct response. 55.19. What is the ratio of the Emissions(in percent) in Gaseous fuel in 1999 to that in 2000?
Your answer should be very brief. 1.24. What is the ratio of the Emissions(in percent) of Liquid fuel in 1999 to that in 2000?
Provide a short and direct response. 0.93. What is the ratio of the Emissions(in percent) of Solid fuel in 1999 to that in 2000?
Your answer should be very brief. 0.96. What is the ratio of the Emissions(in percent) of Gaseous fuel in 1999 to that in 2001?
Ensure brevity in your answer.  0.84. What is the ratio of the Emissions(in percent) in Liquid fuel in 1999 to that in 2001?
Provide a succinct answer. 1.06. What is the ratio of the Emissions(in percent) of Solid fuel in 1999 to that in 2001?
Your answer should be very brief. 1.13. What is the ratio of the Emissions(in percent) in Gaseous fuel in 1999 to that in 2002?
Give a very brief answer. 1.1. What is the ratio of the Emissions(in percent) in Liquid fuel in 1999 to that in 2002?
Your answer should be compact. 0.92. What is the ratio of the Emissions(in percent) in Solid fuel in 1999 to that in 2002?
Keep it short and to the point. 1.2. What is the ratio of the Emissions(in percent) of Gaseous fuel in 1999 to that in 2003?
Make the answer very short. 1.25. What is the ratio of the Emissions(in percent) of Liquid fuel in 1999 to that in 2003?
Provide a short and direct response. 0.85. What is the ratio of the Emissions(in percent) of Solid fuel in 1999 to that in 2003?
Keep it short and to the point. 1.4. What is the ratio of the Emissions(in percent) in Gaseous fuel in 1999 to that in 2004?
Offer a very short reply. 1.26. What is the ratio of the Emissions(in percent) in Liquid fuel in 1999 to that in 2004?
Your answer should be very brief. 0.87. What is the ratio of the Emissions(in percent) in Solid fuel in 1999 to that in 2004?
Give a very brief answer. 1.19. What is the ratio of the Emissions(in percent) of Gaseous fuel in 1999 to that in 2005?
Ensure brevity in your answer.  1.24. What is the ratio of the Emissions(in percent) of Liquid fuel in 1999 to that in 2005?
Your answer should be compact. 0.86. What is the ratio of the Emissions(in percent) of Solid fuel in 1999 to that in 2005?
Your answer should be very brief. 1.42. What is the ratio of the Emissions(in percent) of Gaseous fuel in 1999 to that in 2006?
Offer a terse response. 1.31. What is the ratio of the Emissions(in percent) in Liquid fuel in 1999 to that in 2006?
Keep it short and to the point. 0.83. What is the ratio of the Emissions(in percent) in Solid fuel in 1999 to that in 2006?
Your response must be concise. 1.61. What is the ratio of the Emissions(in percent) of Gaseous fuel in 1999 to that in 2007?
Your answer should be compact. 1.1. What is the ratio of the Emissions(in percent) of Liquid fuel in 1999 to that in 2007?
Keep it short and to the point. 0.92. What is the ratio of the Emissions(in percent) in Solid fuel in 1999 to that in 2007?
Your answer should be compact. 1.45. What is the ratio of the Emissions(in percent) of Gaseous fuel in 2000 to that in 2001?
Make the answer very short. 0.68. What is the ratio of the Emissions(in percent) of Liquid fuel in 2000 to that in 2001?
Offer a terse response. 1.14. What is the ratio of the Emissions(in percent) in Solid fuel in 2000 to that in 2001?
Offer a very short reply. 1.18. What is the ratio of the Emissions(in percent) of Gaseous fuel in 2000 to that in 2002?
Keep it short and to the point. 0.89. What is the ratio of the Emissions(in percent) in Liquid fuel in 2000 to that in 2002?
Offer a terse response. 0.99. What is the ratio of the Emissions(in percent) of Solid fuel in 2000 to that in 2002?
Provide a succinct answer. 1.25. What is the ratio of the Emissions(in percent) in Gaseous fuel in 2000 to that in 2003?
Offer a very short reply. 1.01. What is the ratio of the Emissions(in percent) of Liquid fuel in 2000 to that in 2003?
Offer a terse response. 0.92. What is the ratio of the Emissions(in percent) of Solid fuel in 2000 to that in 2003?
Offer a terse response. 1.46. What is the ratio of the Emissions(in percent) in Gaseous fuel in 2000 to that in 2004?
Your answer should be very brief. 1.02. What is the ratio of the Emissions(in percent) in Solid fuel in 2000 to that in 2004?
Provide a succinct answer. 1.25. What is the ratio of the Emissions(in percent) in Liquid fuel in 2000 to that in 2005?
Make the answer very short. 0.92. What is the ratio of the Emissions(in percent) in Solid fuel in 2000 to that in 2005?
Your answer should be compact. 1.48. What is the ratio of the Emissions(in percent) of Gaseous fuel in 2000 to that in 2006?
Your answer should be compact. 1.06. What is the ratio of the Emissions(in percent) of Liquid fuel in 2000 to that in 2006?
Your answer should be compact. 0.89. What is the ratio of the Emissions(in percent) of Solid fuel in 2000 to that in 2006?
Give a very brief answer. 1.69. What is the ratio of the Emissions(in percent) of Gaseous fuel in 2000 to that in 2007?
Your answer should be compact. 0.89. What is the ratio of the Emissions(in percent) of Solid fuel in 2000 to that in 2007?
Your answer should be very brief. 1.52. What is the ratio of the Emissions(in percent) in Gaseous fuel in 2001 to that in 2002?
Ensure brevity in your answer.  1.31. What is the ratio of the Emissions(in percent) of Liquid fuel in 2001 to that in 2002?
Provide a succinct answer. 0.87. What is the ratio of the Emissions(in percent) in Solid fuel in 2001 to that in 2002?
Keep it short and to the point. 1.06. What is the ratio of the Emissions(in percent) in Gaseous fuel in 2001 to that in 2003?
Offer a terse response. 1.49. What is the ratio of the Emissions(in percent) of Liquid fuel in 2001 to that in 2003?
Offer a very short reply. 0.81. What is the ratio of the Emissions(in percent) in Solid fuel in 2001 to that in 2003?
Offer a terse response. 1.24. What is the ratio of the Emissions(in percent) in Gaseous fuel in 2001 to that in 2004?
Offer a terse response. 1.49. What is the ratio of the Emissions(in percent) in Liquid fuel in 2001 to that in 2004?
Provide a short and direct response. 0.82. What is the ratio of the Emissions(in percent) of Solid fuel in 2001 to that in 2004?
Provide a succinct answer. 1.06. What is the ratio of the Emissions(in percent) in Gaseous fuel in 2001 to that in 2005?
Keep it short and to the point. 1.47. What is the ratio of the Emissions(in percent) in Liquid fuel in 2001 to that in 2005?
Your response must be concise. 0.81. What is the ratio of the Emissions(in percent) in Solid fuel in 2001 to that in 2005?
Provide a succinct answer. 1.25. What is the ratio of the Emissions(in percent) in Gaseous fuel in 2001 to that in 2006?
Keep it short and to the point. 1.56. What is the ratio of the Emissions(in percent) of Liquid fuel in 2001 to that in 2006?
Keep it short and to the point. 0.78. What is the ratio of the Emissions(in percent) in Solid fuel in 2001 to that in 2006?
Provide a short and direct response. 1.43. What is the ratio of the Emissions(in percent) in Gaseous fuel in 2001 to that in 2007?
Your answer should be very brief. 1.31. What is the ratio of the Emissions(in percent) of Liquid fuel in 2001 to that in 2007?
Your answer should be very brief. 0.87. What is the ratio of the Emissions(in percent) in Solid fuel in 2001 to that in 2007?
Your answer should be compact. 1.28. What is the ratio of the Emissions(in percent) in Gaseous fuel in 2002 to that in 2003?
Offer a terse response. 1.14. What is the ratio of the Emissions(in percent) in Liquid fuel in 2002 to that in 2003?
Ensure brevity in your answer.  0.93. What is the ratio of the Emissions(in percent) in Solid fuel in 2002 to that in 2003?
Ensure brevity in your answer.  1.17. What is the ratio of the Emissions(in percent) in Gaseous fuel in 2002 to that in 2004?
Keep it short and to the point. 1.14. What is the ratio of the Emissions(in percent) in Liquid fuel in 2002 to that in 2004?
Ensure brevity in your answer.  0.95. What is the ratio of the Emissions(in percent) of Solid fuel in 2002 to that in 2004?
Provide a succinct answer. 1. What is the ratio of the Emissions(in percent) of Gaseous fuel in 2002 to that in 2005?
Your answer should be compact. 1.13. What is the ratio of the Emissions(in percent) of Liquid fuel in 2002 to that in 2005?
Give a very brief answer. 0.93. What is the ratio of the Emissions(in percent) in Solid fuel in 2002 to that in 2005?
Offer a terse response. 1.18. What is the ratio of the Emissions(in percent) in Gaseous fuel in 2002 to that in 2006?
Keep it short and to the point. 1.19. What is the ratio of the Emissions(in percent) in Liquid fuel in 2002 to that in 2006?
Your response must be concise. 0.9. What is the ratio of the Emissions(in percent) in Solid fuel in 2002 to that in 2006?
Keep it short and to the point. 1.35. What is the ratio of the Emissions(in percent) of Liquid fuel in 2002 to that in 2007?
Your response must be concise. 1.01. What is the ratio of the Emissions(in percent) in Solid fuel in 2002 to that in 2007?
Make the answer very short. 1.21. What is the ratio of the Emissions(in percent) in Gaseous fuel in 2003 to that in 2004?
Ensure brevity in your answer.  1. What is the ratio of the Emissions(in percent) in Liquid fuel in 2003 to that in 2004?
Make the answer very short. 1.02. What is the ratio of the Emissions(in percent) of Solid fuel in 2003 to that in 2004?
Offer a very short reply. 0.85. What is the ratio of the Emissions(in percent) of Gaseous fuel in 2003 to that in 2005?
Offer a terse response. 0.99. What is the ratio of the Emissions(in percent) of Liquid fuel in 2003 to that in 2005?
Ensure brevity in your answer.  1. What is the ratio of the Emissions(in percent) in Solid fuel in 2003 to that in 2005?
Offer a very short reply. 1.01. What is the ratio of the Emissions(in percent) of Gaseous fuel in 2003 to that in 2006?
Provide a succinct answer. 1.05. What is the ratio of the Emissions(in percent) of Liquid fuel in 2003 to that in 2006?
Your answer should be very brief. 0.97. What is the ratio of the Emissions(in percent) of Solid fuel in 2003 to that in 2006?
Offer a terse response. 1.15. What is the ratio of the Emissions(in percent) in Gaseous fuel in 2003 to that in 2007?
Your answer should be very brief. 0.88. What is the ratio of the Emissions(in percent) in Liquid fuel in 2003 to that in 2007?
Provide a succinct answer. 1.08. What is the ratio of the Emissions(in percent) in Solid fuel in 2003 to that in 2007?
Provide a succinct answer. 1.04. What is the ratio of the Emissions(in percent) in Liquid fuel in 2004 to that in 2005?
Your answer should be compact. 0.99. What is the ratio of the Emissions(in percent) in Solid fuel in 2004 to that in 2005?
Offer a terse response. 1.19. What is the ratio of the Emissions(in percent) of Gaseous fuel in 2004 to that in 2006?
Your answer should be compact. 1.04. What is the ratio of the Emissions(in percent) of Liquid fuel in 2004 to that in 2006?
Give a very brief answer. 0.95. What is the ratio of the Emissions(in percent) in Solid fuel in 2004 to that in 2006?
Keep it short and to the point. 1.35. What is the ratio of the Emissions(in percent) in Gaseous fuel in 2004 to that in 2007?
Make the answer very short. 0.88. What is the ratio of the Emissions(in percent) of Liquid fuel in 2004 to that in 2007?
Make the answer very short. 1.06. What is the ratio of the Emissions(in percent) of Solid fuel in 2004 to that in 2007?
Offer a very short reply. 1.22. What is the ratio of the Emissions(in percent) in Gaseous fuel in 2005 to that in 2006?
Make the answer very short. 1.06. What is the ratio of the Emissions(in percent) of Liquid fuel in 2005 to that in 2006?
Offer a very short reply. 0.97. What is the ratio of the Emissions(in percent) of Solid fuel in 2005 to that in 2006?
Your response must be concise. 1.14. What is the ratio of the Emissions(in percent) in Gaseous fuel in 2005 to that in 2007?
Provide a short and direct response. 0.89. What is the ratio of the Emissions(in percent) of Liquid fuel in 2005 to that in 2007?
Ensure brevity in your answer.  1.08. What is the ratio of the Emissions(in percent) in Solid fuel in 2005 to that in 2007?
Make the answer very short. 1.03. What is the ratio of the Emissions(in percent) in Gaseous fuel in 2006 to that in 2007?
Your answer should be compact. 0.84. What is the ratio of the Emissions(in percent) in Liquid fuel in 2006 to that in 2007?
Provide a succinct answer. 1.12. What is the ratio of the Emissions(in percent) in Solid fuel in 2006 to that in 2007?
Give a very brief answer. 0.9. What is the difference between the highest and the second highest Emissions(in percent) of Gaseous fuel?
Offer a terse response. 5.1. What is the difference between the highest and the second highest Emissions(in percent) of Liquid fuel?
Your answer should be very brief. 2.08. What is the difference between the highest and the second highest Emissions(in percent) in Solid fuel?
Give a very brief answer. 0.45. What is the difference between the highest and the lowest Emissions(in percent) in Gaseous fuel?
Make the answer very short. 11.59. What is the difference between the highest and the lowest Emissions(in percent) of Liquid fuel?
Your response must be concise. 15.09. What is the difference between the highest and the lowest Emissions(in percent) of Solid fuel?
Provide a short and direct response. 4.18. 